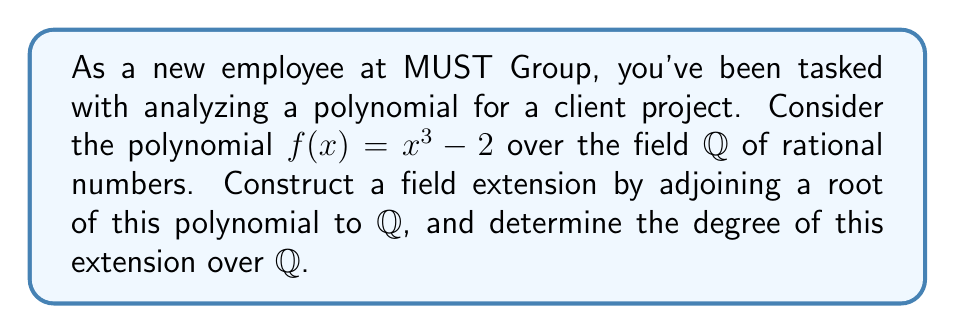Solve this math problem. Let's approach this step-by-step:

1) First, we need to identify a root of $f(x) = x^3 - 2$. Let's call this root $\alpha$. So, $\alpha^3 = 2$.

2) The field extension we're constructing is $\mathbb{Q}(\alpha)$, which is the smallest field containing both $\mathbb{Q}$ and $\alpha$.

3) To determine the degree of this extension, we need to find the minimal polynomial of $\alpha$ over $\mathbb{Q}$.

4) The polynomial $f(x) = x^3 - 2$ is irreducible over $\mathbb{Q}$ by Eisenstein's criterion (using prime $p=2$). 

5) Since $f(\alpha) = 0$ and $f(x)$ is irreducible, $f(x)$ is the minimal polynomial of $\alpha$ over $\mathbb{Q}$.

6) The degree of the field extension $[\mathbb{Q}(\alpha):\mathbb{Q}]$ is equal to the degree of the minimal polynomial of $\alpha$.

7) The degree of $f(x) = x^3 - 2$ is 3.

Therefore, the degree of the field extension $[\mathbb{Q}(\alpha):\mathbb{Q}]$ is 3.
Answer: 3 